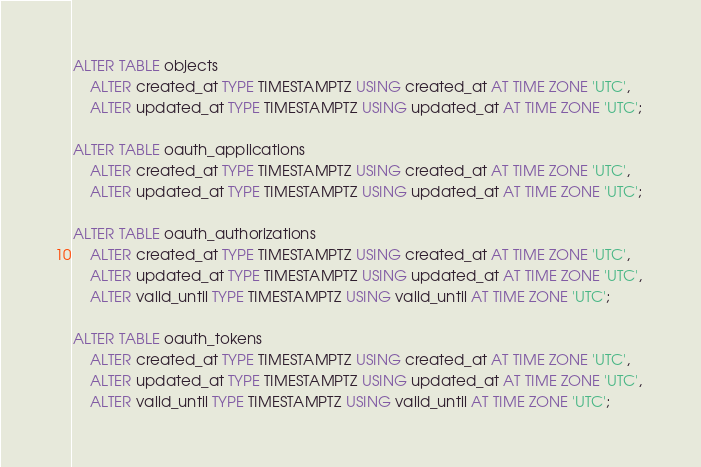<code> <loc_0><loc_0><loc_500><loc_500><_SQL_>ALTER TABLE objects 
    ALTER created_at TYPE TIMESTAMPTZ USING created_at AT TIME ZONE 'UTC', 
    ALTER updated_at TYPE TIMESTAMPTZ USING updated_at AT TIME ZONE 'UTC';

ALTER TABLE oauth_applications 
    ALTER created_at TYPE TIMESTAMPTZ USING created_at AT TIME ZONE 'UTC', 
    ALTER updated_at TYPE TIMESTAMPTZ USING updated_at AT TIME ZONE 'UTC';

ALTER TABLE oauth_authorizations 
    ALTER created_at TYPE TIMESTAMPTZ USING created_at AT TIME ZONE 'UTC', 
    ALTER updated_at TYPE TIMESTAMPTZ USING updated_at AT TIME ZONE 'UTC', 
    ALTER valid_until TYPE TIMESTAMPTZ USING valid_until AT TIME ZONE 'UTC';

ALTER TABLE oauth_tokens 
    ALTER created_at TYPE TIMESTAMPTZ USING created_at AT TIME ZONE 'UTC', 
    ALTER updated_at TYPE TIMESTAMPTZ USING updated_at AT TIME ZONE 'UTC', 
    ALTER valid_until TYPE TIMESTAMPTZ USING valid_until AT TIME ZONE 'UTC';
</code> 